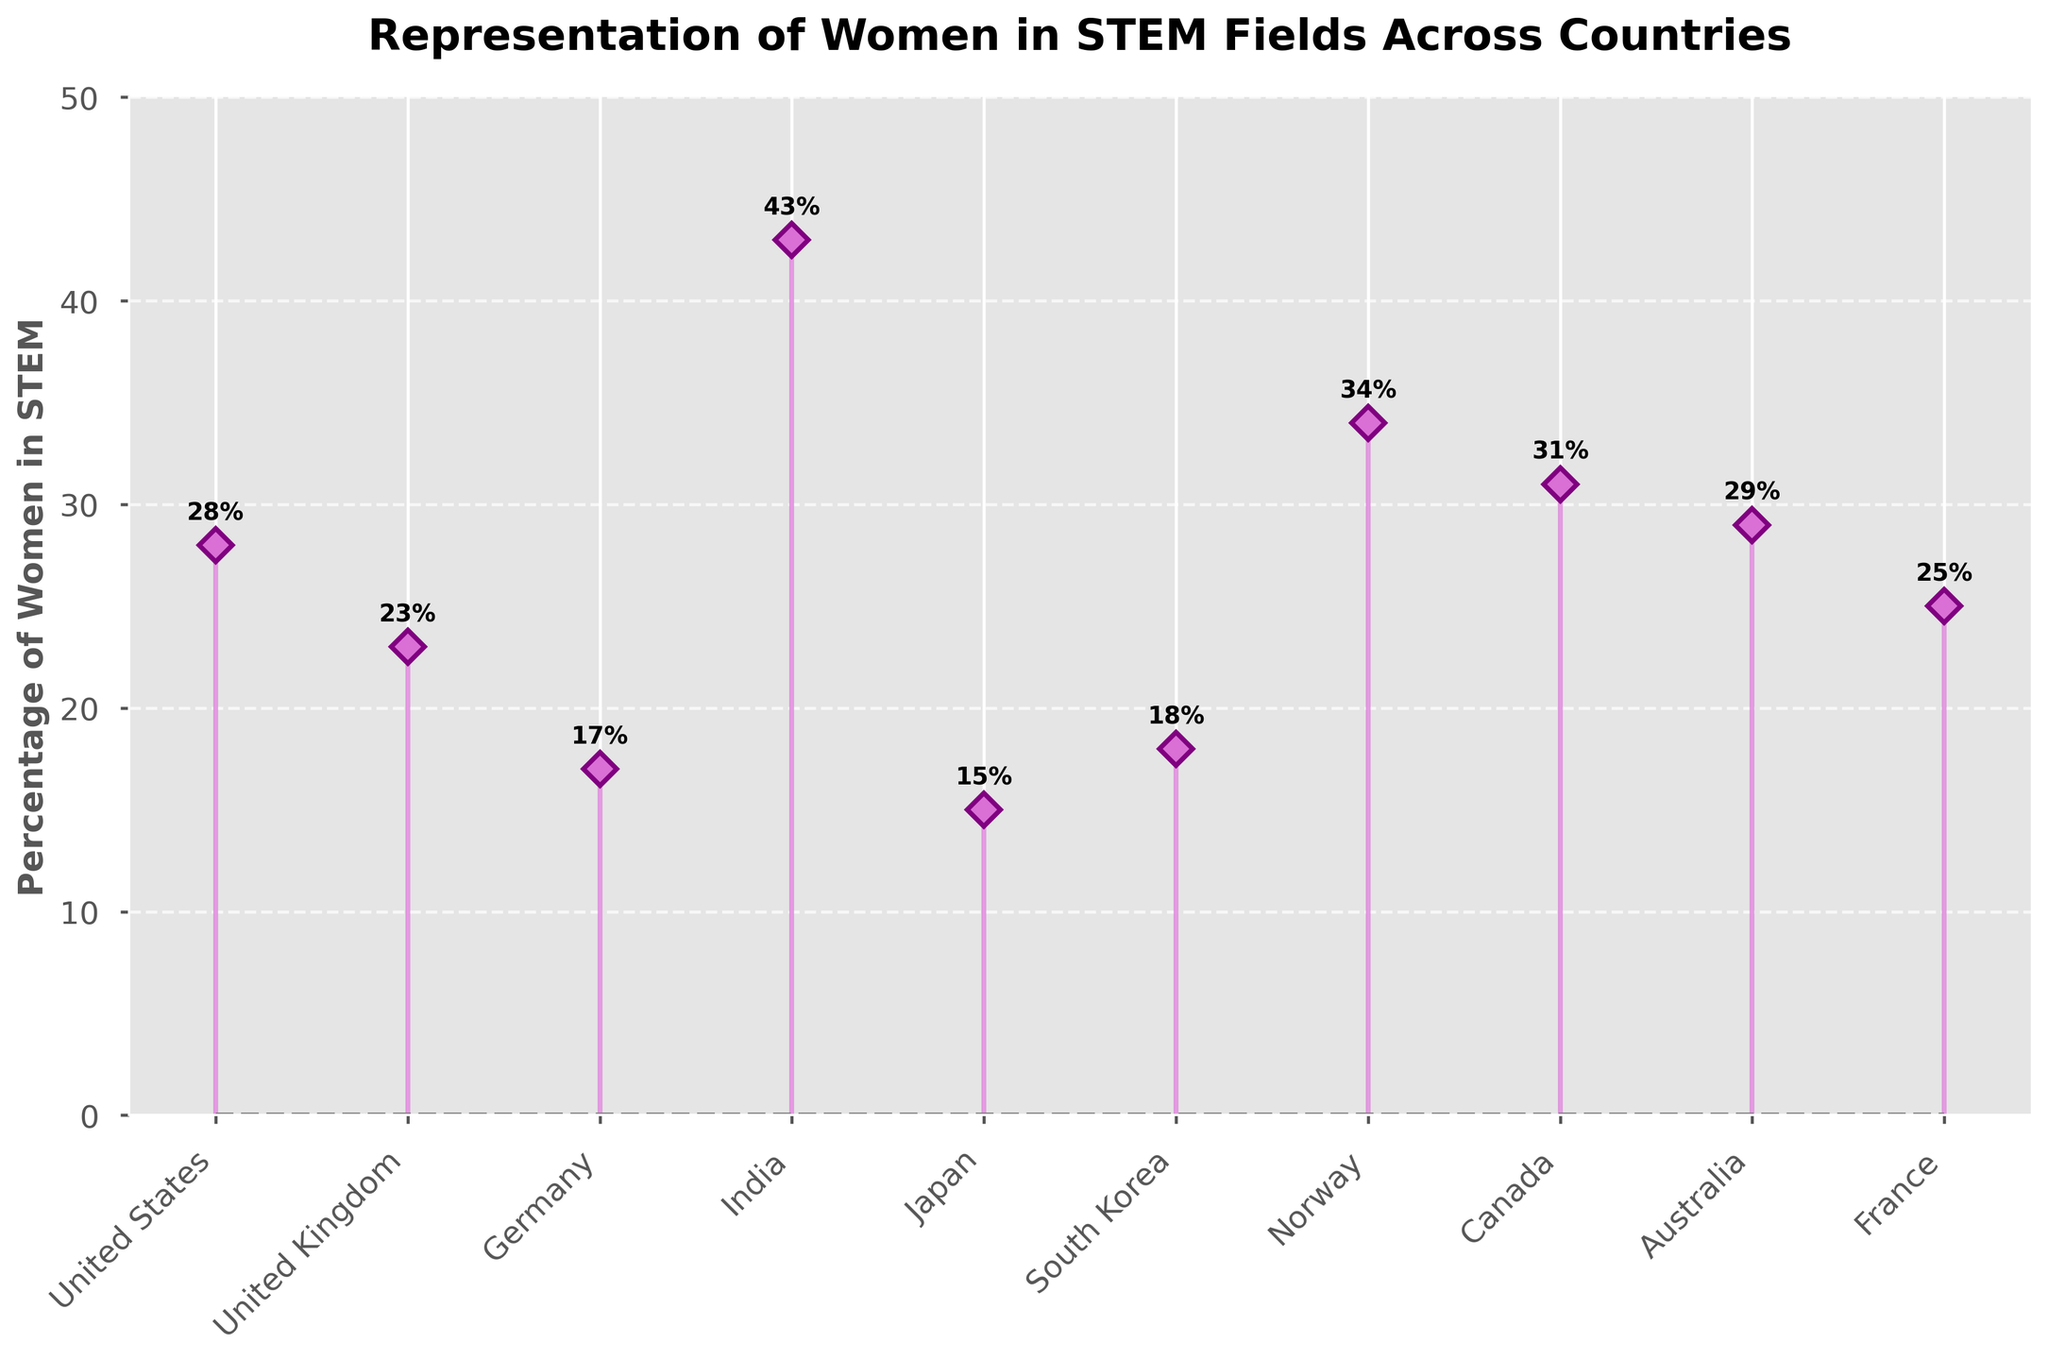What is the title of the plot? The title is located at the top of the figure in large, bold text. It states the overall theme of the figure.
Answer: Representation of Women in STEM Fields Across Countries What is the y-axis labeled as? The y-axis label is positioned vertically on the left side of the figure. It indicates what the numerical values represent.
Answer: Percentage of Women in STEM How many countries have more than 30% of women in STEM fields? To find this, count the countries with percentages above 30 on the y-axis. Use the labels and data points plotted for reference.
Answer: Three Which country has the highest percentage of women in STEM fields? Identify the tallest stem plot and read the corresponding country label on the x-axis.
Answer: India How does the percentage of women in STEM in Germany compare to that in Canada? Look at the heights of the stems for Germany and Canada. Find the numerical difference by subtracting Germany's percentage from Canada's.
Answer: Canada has 14% more What is the average percentage of women in STEM across all listed countries? Add all the percentages together and divide by the total number of countries (10).
Answer: 26.3% Which countries have a lower percentage of women in STEM than the United States? Compare the value for the United States (28%) with other countries and list those with smaller percentages.
Answer: United Kingdom, Germany, Japan, South Korea, France What is the range of the percentage values? Identify the maximum and minimum values on the y-axis and calculate the difference between them.
Answer: 28% Which country has the lowest percentage of women in STEM fields and what is that percentage? Find the shortest stem plot and read the country label and its value.
Answer: Japan, 15% How many countries have a percentage of women in STEM between 20% and 30%? Count the number of stems that fall within the 20%-30% range on the y-axis.
Answer: Four 